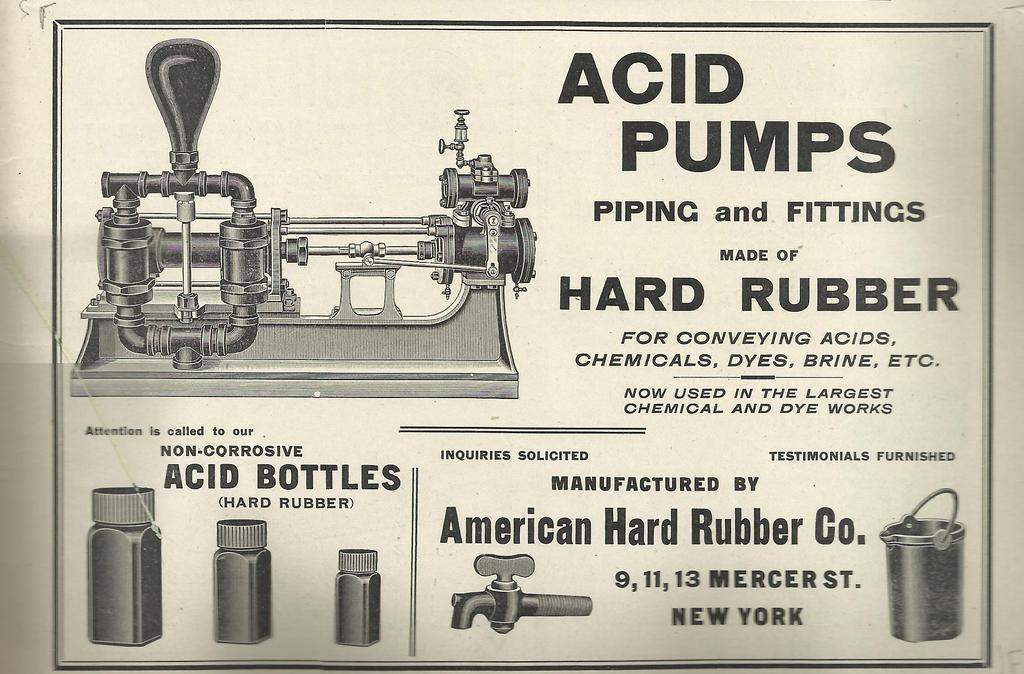<image>
Describe the image concisely. An older ad that says Acid Pumps Piping and Fittings on it. 